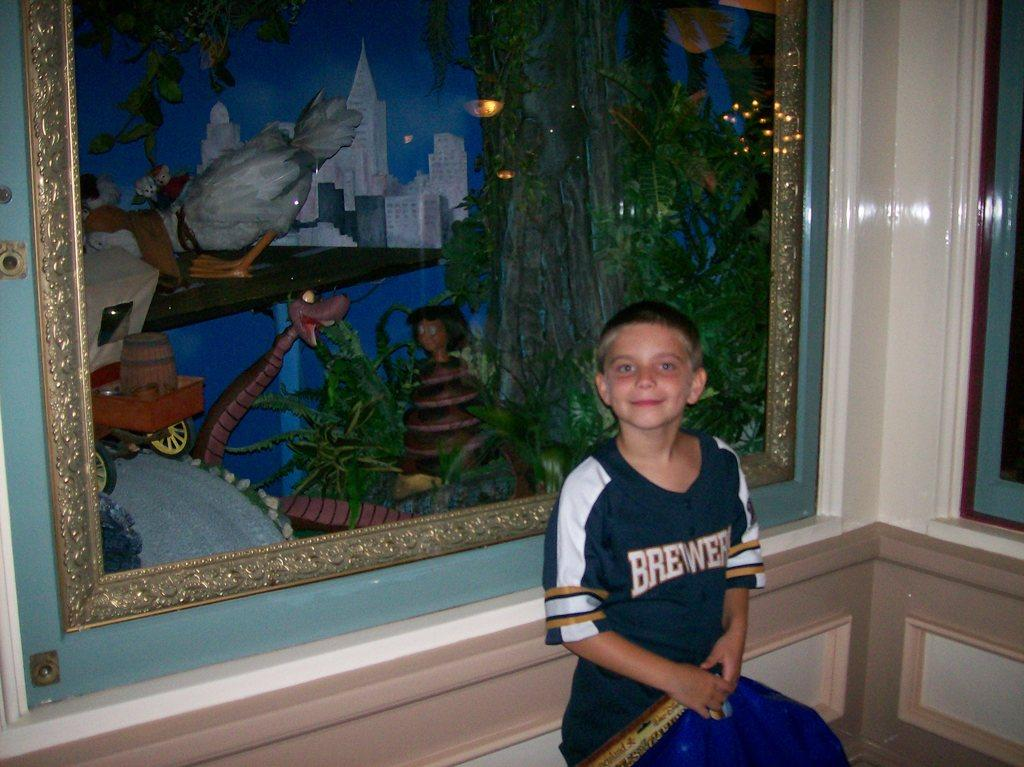<image>
Present a compact description of the photo's key features. A boy in a Brewers jersey stands in front of a framed picture. 